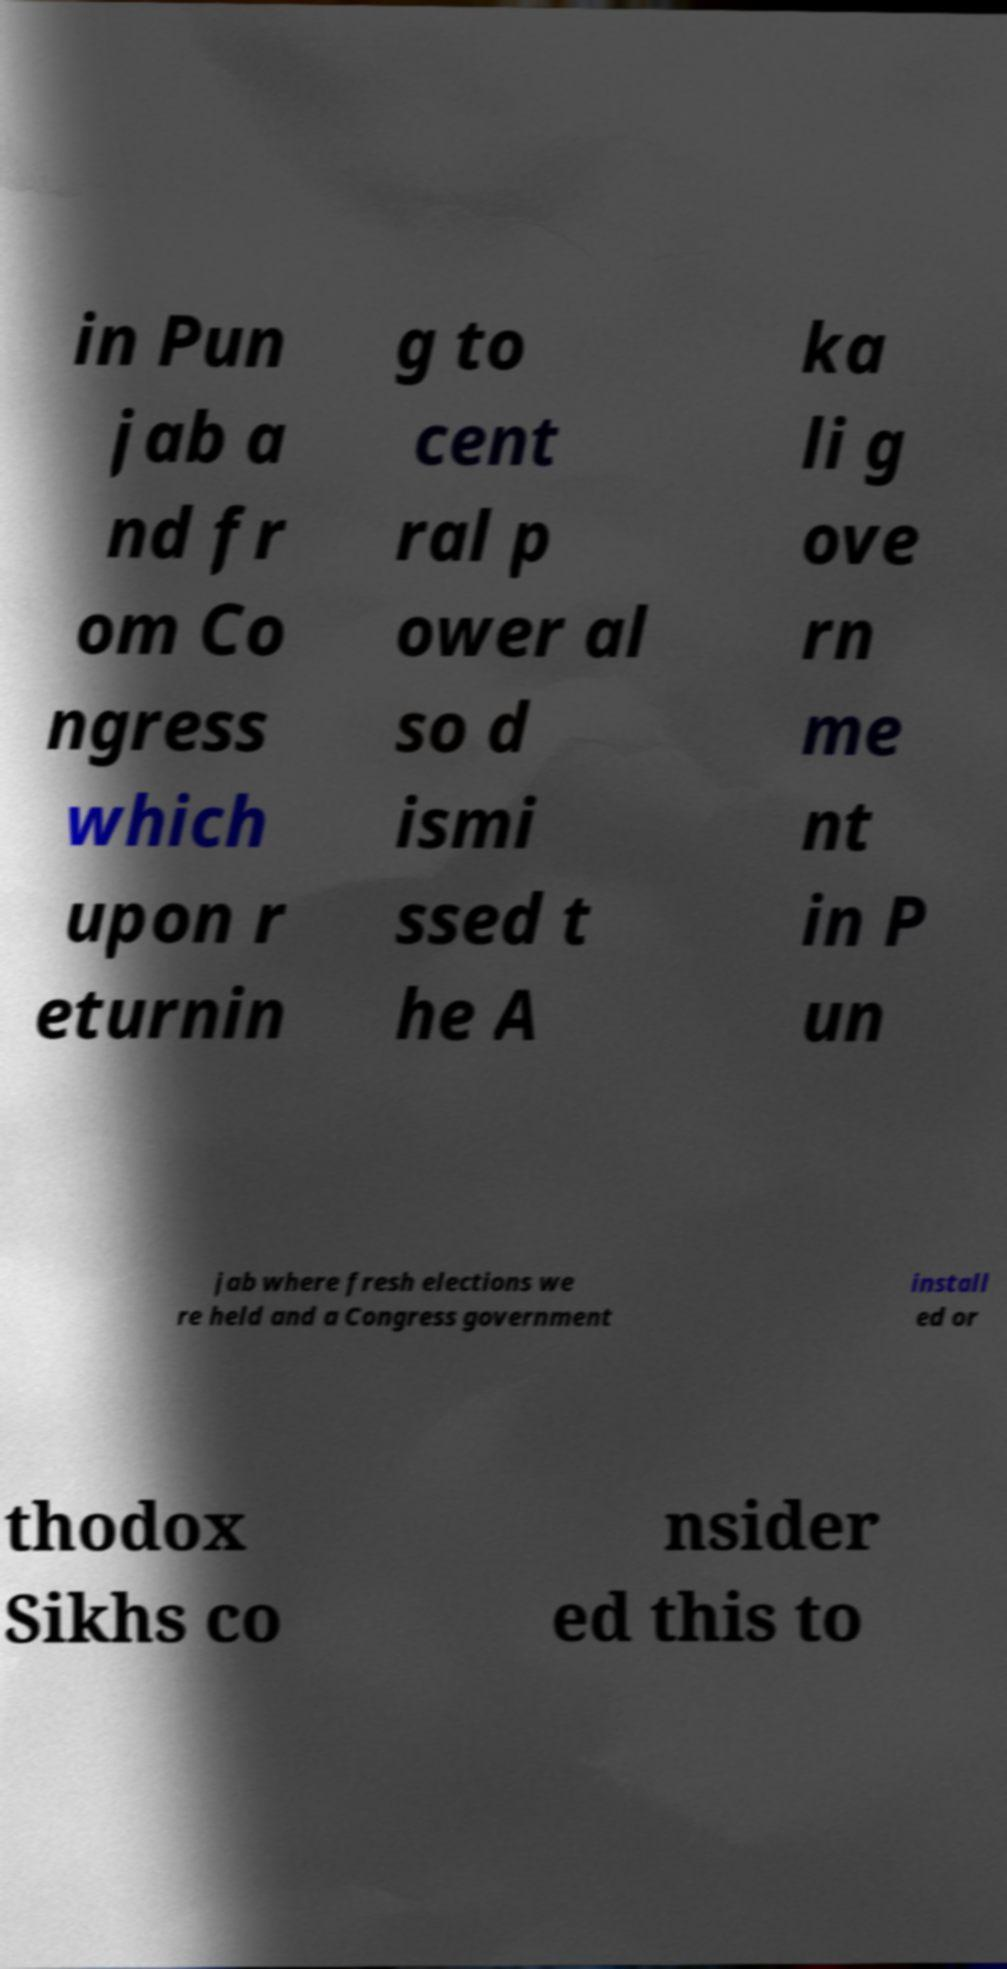There's text embedded in this image that I need extracted. Can you transcribe it verbatim? in Pun jab a nd fr om Co ngress which upon r eturnin g to cent ral p ower al so d ismi ssed t he A ka li g ove rn me nt in P un jab where fresh elections we re held and a Congress government install ed or thodox Sikhs co nsider ed this to 